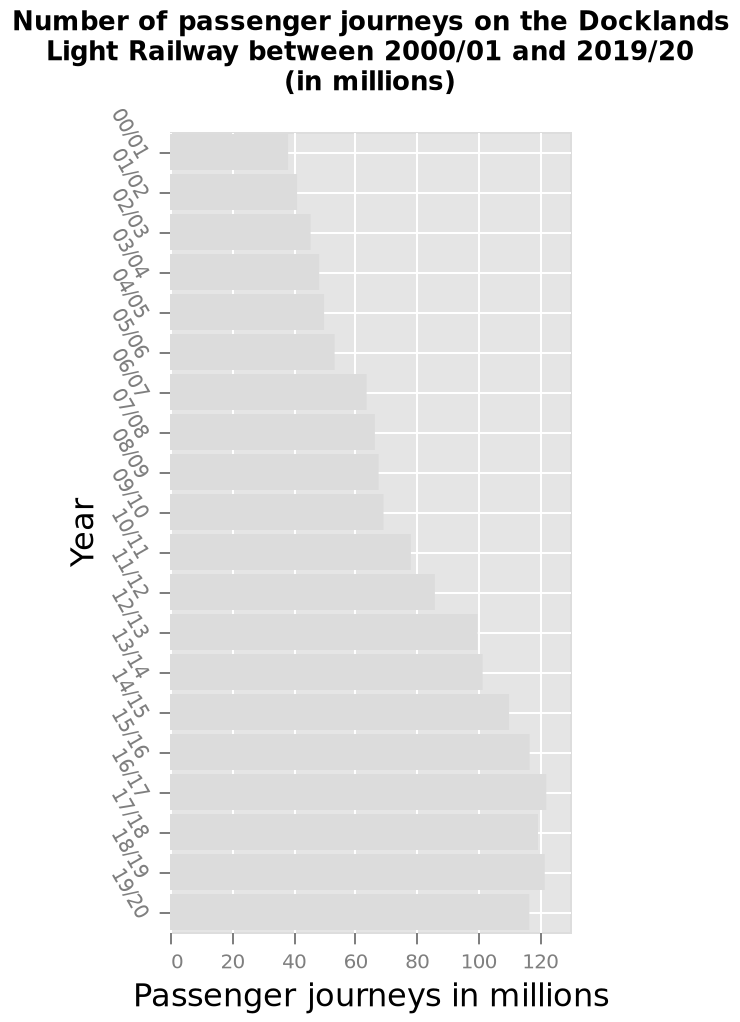<image>
What does the y-axis represent on the bar graph? The y-axis represents the years from 00/01 to 19/20 on a categorical scale. By what factor did the number of journeys increase during the years shown?  The number of journeys almost tripled during the years. 